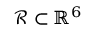Convert formula to latex. <formula><loc_0><loc_0><loc_500><loc_500>\mathcal { R } \subset \mathbb { R } ^ { 6 }</formula> 